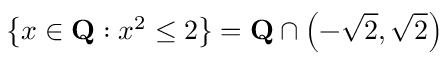<formula> <loc_0><loc_0><loc_500><loc_500>\left \{ x \in Q \colon x ^ { 2 } \leq 2 \right \} = Q \cap \left ( - { \sqrt { 2 } } , { \sqrt { 2 } } \right )</formula> 